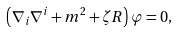<formula> <loc_0><loc_0><loc_500><loc_500>\left ( \nabla _ { i } \nabla ^ { i } + m ^ { 2 } + \zeta R \right ) \varphi = 0 ,</formula> 